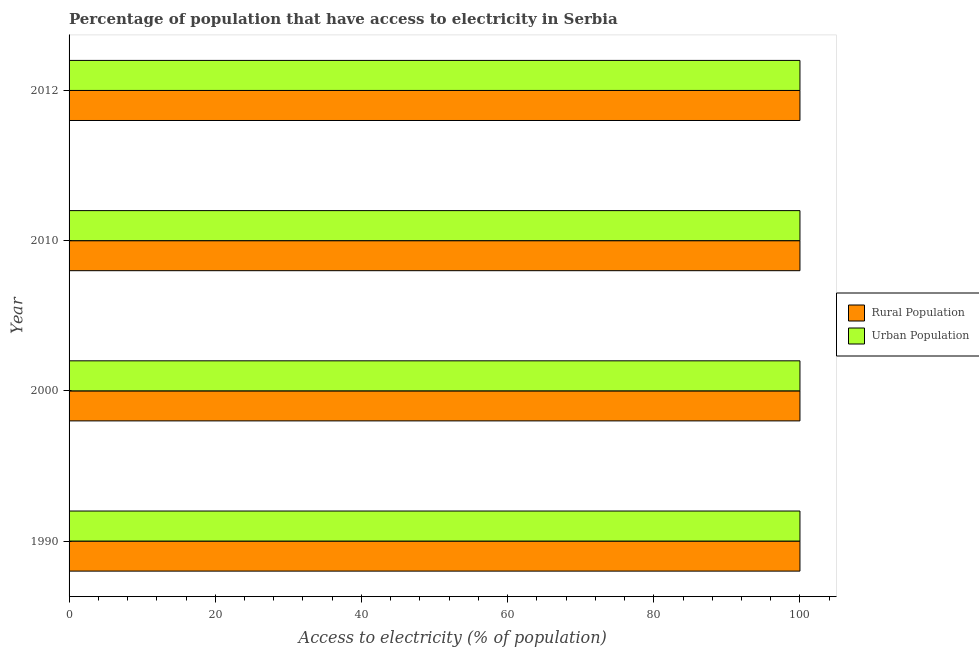How many groups of bars are there?
Offer a very short reply. 4. Are the number of bars per tick equal to the number of legend labels?
Provide a succinct answer. Yes. Are the number of bars on each tick of the Y-axis equal?
Offer a terse response. Yes. What is the label of the 1st group of bars from the top?
Keep it short and to the point. 2012. What is the percentage of urban population having access to electricity in 1990?
Your answer should be very brief. 100. Across all years, what is the maximum percentage of rural population having access to electricity?
Offer a terse response. 100. Across all years, what is the minimum percentage of rural population having access to electricity?
Your response must be concise. 100. In which year was the percentage of rural population having access to electricity maximum?
Give a very brief answer. 1990. What is the total percentage of rural population having access to electricity in the graph?
Provide a short and direct response. 400. What is the difference between the percentage of urban population having access to electricity in 2010 and that in 2012?
Ensure brevity in your answer.  0. What is the difference between the percentage of rural population having access to electricity in 2000 and the percentage of urban population having access to electricity in 2010?
Ensure brevity in your answer.  0. What is the average percentage of urban population having access to electricity per year?
Make the answer very short. 100. In how many years, is the percentage of urban population having access to electricity greater than 12 %?
Your answer should be compact. 4. What is the ratio of the percentage of rural population having access to electricity in 2000 to that in 2012?
Provide a short and direct response. 1. Is the difference between the percentage of urban population having access to electricity in 1990 and 2010 greater than the difference between the percentage of rural population having access to electricity in 1990 and 2010?
Give a very brief answer. No. In how many years, is the percentage of rural population having access to electricity greater than the average percentage of rural population having access to electricity taken over all years?
Ensure brevity in your answer.  0. What does the 1st bar from the top in 2000 represents?
Make the answer very short. Urban Population. What does the 2nd bar from the bottom in 2000 represents?
Offer a terse response. Urban Population. How many bars are there?
Offer a terse response. 8. Are the values on the major ticks of X-axis written in scientific E-notation?
Ensure brevity in your answer.  No. Does the graph contain any zero values?
Provide a succinct answer. No. How many legend labels are there?
Your answer should be very brief. 2. What is the title of the graph?
Provide a short and direct response. Percentage of population that have access to electricity in Serbia. What is the label or title of the X-axis?
Make the answer very short. Access to electricity (% of population). What is the Access to electricity (% of population) in Rural Population in 1990?
Give a very brief answer. 100. What is the Access to electricity (% of population) of Rural Population in 2000?
Your response must be concise. 100. What is the Access to electricity (% of population) in Rural Population in 2010?
Offer a very short reply. 100. What is the Access to electricity (% of population) in Urban Population in 2010?
Give a very brief answer. 100. Across all years, what is the maximum Access to electricity (% of population) in Rural Population?
Offer a terse response. 100. Across all years, what is the maximum Access to electricity (% of population) in Urban Population?
Offer a terse response. 100. Across all years, what is the minimum Access to electricity (% of population) in Rural Population?
Provide a short and direct response. 100. What is the total Access to electricity (% of population) of Rural Population in the graph?
Make the answer very short. 400. What is the difference between the Access to electricity (% of population) of Rural Population in 1990 and that in 2000?
Give a very brief answer. 0. What is the difference between the Access to electricity (% of population) of Urban Population in 1990 and that in 2000?
Your response must be concise. 0. What is the difference between the Access to electricity (% of population) of Urban Population in 1990 and that in 2010?
Offer a very short reply. 0. What is the difference between the Access to electricity (% of population) in Rural Population in 2000 and that in 2010?
Keep it short and to the point. 0. What is the difference between the Access to electricity (% of population) of Urban Population in 2000 and that in 2010?
Offer a terse response. 0. What is the difference between the Access to electricity (% of population) of Urban Population in 2000 and that in 2012?
Offer a very short reply. 0. What is the difference between the Access to electricity (% of population) in Urban Population in 2010 and that in 2012?
Keep it short and to the point. 0. What is the difference between the Access to electricity (% of population) of Rural Population in 1990 and the Access to electricity (% of population) of Urban Population in 2010?
Your answer should be very brief. 0. What is the difference between the Access to electricity (% of population) in Rural Population in 2010 and the Access to electricity (% of population) in Urban Population in 2012?
Your answer should be compact. 0. In the year 2010, what is the difference between the Access to electricity (% of population) of Rural Population and Access to electricity (% of population) of Urban Population?
Ensure brevity in your answer.  0. What is the ratio of the Access to electricity (% of population) of Urban Population in 1990 to that in 2000?
Offer a terse response. 1. What is the ratio of the Access to electricity (% of population) in Urban Population in 1990 to that in 2012?
Your answer should be compact. 1. What is the ratio of the Access to electricity (% of population) in Rural Population in 2000 to that in 2010?
Keep it short and to the point. 1. What is the ratio of the Access to electricity (% of population) in Urban Population in 2000 to that in 2010?
Give a very brief answer. 1. What is the ratio of the Access to electricity (% of population) of Urban Population in 2000 to that in 2012?
Ensure brevity in your answer.  1. 